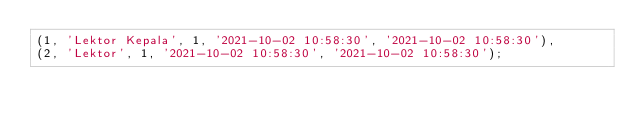<code> <loc_0><loc_0><loc_500><loc_500><_SQL_>(1, 'Lektor Kepala', 1, '2021-10-02 10:58:30', '2021-10-02 10:58:30'),
(2, 'Lektor', 1, '2021-10-02 10:58:30', '2021-10-02 10:58:30');</code> 